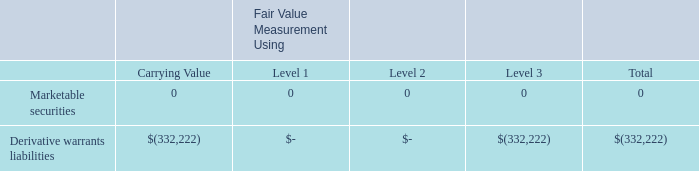The three levels are described below:
Level 1 Inputs – Unadjusted quoted prices in active markets for identical assets or liabilities that is accessible by the Company;
Level 2 Inputs – Quoted prices in markets that are not active or financial instruments for which all significant inputs are observable, either directly or indirectly;
Level 3 Inputs – Unobservable inputs for the asset or liability including significant assumptions of the Company and other market participants.
The carrying amount of the Company’s financial assets and liabilities, such as cash, accounts payable and accrued expenses approximate their fair value because of
the short maturity of those instruments. The carrying amount of the Company’s financial assets and liabilities, such as cash, accounts payable and accrued expenses approximate their fair value because of the short maturity of those instruments.
Transactions involving related parties cannot be presumed to be carried out on an arm’s-length basis, as the requisite conditions of competitive, free-market dealings
may not exist. Representations about transactions with related parties, if made, shall not imply that the related party transactions were consummated on terms equivalent to
those that prevail in arm’s-length transactions unless such representations can be substantiated.
The assets or liability’s fair value measurement within the fair value hierarchy is based upon the lowest level of any input that is significant to the fair value measurement. The following table provides a summary of financial instruments that are measured at fair value as of December 31, 2019.
What does a Level 1 input refer to? Unadjusted quoted prices in active markets for identical assets or liabilities that is accessible by the company. What does a Level 2 input refer to? Quoted prices in markets that are not active or financial instruments for which all significant inputs are observable, either directly or indirectly. What does a Level 3 input refer to? Unobservable inputs for the asset or liability including significant assumptions of the company and other market participants. What is the difference in Level 1 and Level 2 marketable securities? 0 -0 
Answer: 0. What is the total Level 3 marketable securities and derivative warrants liabilities?  332,222 + 0 
Answer: 332222. What percentage of the total financial instruments are marketable securities?
Answer scale should be: percent. 0/332,222 
Answer: 0. 